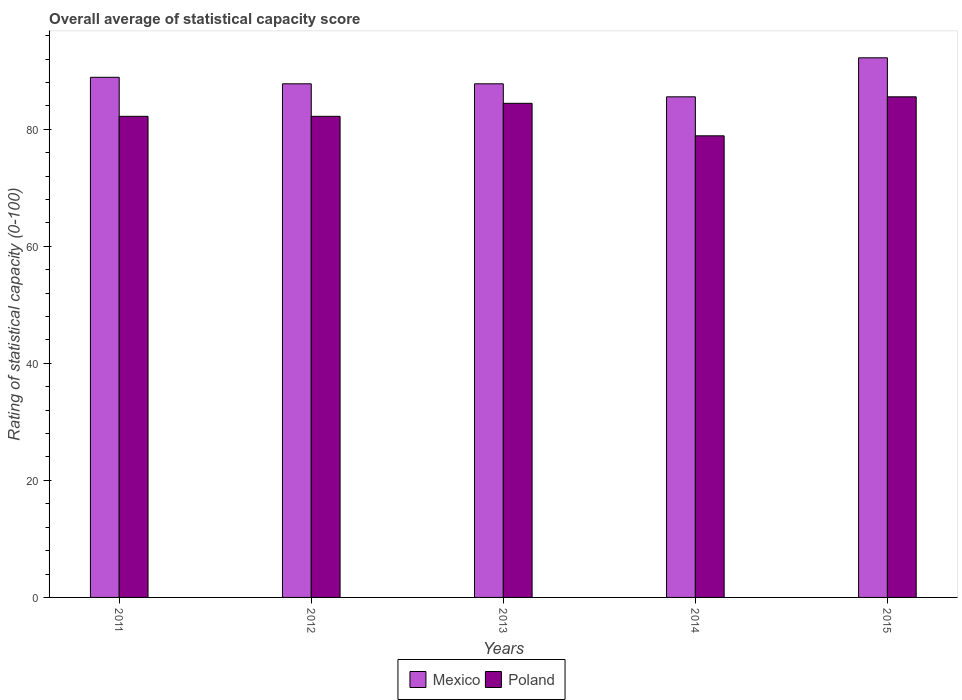Are the number of bars per tick equal to the number of legend labels?
Your answer should be compact. Yes. Are the number of bars on each tick of the X-axis equal?
Offer a terse response. Yes. How many bars are there on the 2nd tick from the right?
Keep it short and to the point. 2. What is the label of the 5th group of bars from the left?
Ensure brevity in your answer.  2015. In how many cases, is the number of bars for a given year not equal to the number of legend labels?
Your answer should be very brief. 0. What is the rating of statistical capacity in Poland in 2012?
Your answer should be very brief. 82.22. Across all years, what is the maximum rating of statistical capacity in Poland?
Make the answer very short. 85.56. Across all years, what is the minimum rating of statistical capacity in Mexico?
Your response must be concise. 85.56. In which year was the rating of statistical capacity in Mexico maximum?
Your answer should be compact. 2015. What is the total rating of statistical capacity in Poland in the graph?
Offer a very short reply. 413.33. What is the difference between the rating of statistical capacity in Mexico in 2014 and that in 2015?
Your answer should be very brief. -6.67. What is the difference between the rating of statistical capacity in Poland in 2015 and the rating of statistical capacity in Mexico in 2014?
Keep it short and to the point. 1.1111111192008138e-5. What is the average rating of statistical capacity in Mexico per year?
Provide a short and direct response. 88.44. In the year 2011, what is the difference between the rating of statistical capacity in Poland and rating of statistical capacity in Mexico?
Your answer should be compact. -6.67. In how many years, is the rating of statistical capacity in Mexico greater than 16?
Ensure brevity in your answer.  5. Is the difference between the rating of statistical capacity in Poland in 2011 and 2013 greater than the difference between the rating of statistical capacity in Mexico in 2011 and 2013?
Provide a succinct answer. No. What is the difference between the highest and the second highest rating of statistical capacity in Poland?
Your response must be concise. 1.11. What is the difference between the highest and the lowest rating of statistical capacity in Poland?
Provide a succinct answer. 6.67. In how many years, is the rating of statistical capacity in Poland greater than the average rating of statistical capacity in Poland taken over all years?
Ensure brevity in your answer.  2. Is the sum of the rating of statistical capacity in Mexico in 2011 and 2015 greater than the maximum rating of statistical capacity in Poland across all years?
Offer a terse response. Yes. What does the 2nd bar from the left in 2013 represents?
Provide a short and direct response. Poland. Are all the bars in the graph horizontal?
Ensure brevity in your answer.  No. Are the values on the major ticks of Y-axis written in scientific E-notation?
Give a very brief answer. No. Does the graph contain any zero values?
Keep it short and to the point. No. Where does the legend appear in the graph?
Your answer should be compact. Bottom center. How are the legend labels stacked?
Make the answer very short. Horizontal. What is the title of the graph?
Offer a terse response. Overall average of statistical capacity score. Does "Latin America(all income levels)" appear as one of the legend labels in the graph?
Make the answer very short. No. What is the label or title of the X-axis?
Provide a short and direct response. Years. What is the label or title of the Y-axis?
Make the answer very short. Rating of statistical capacity (0-100). What is the Rating of statistical capacity (0-100) in Mexico in 2011?
Make the answer very short. 88.89. What is the Rating of statistical capacity (0-100) in Poland in 2011?
Make the answer very short. 82.22. What is the Rating of statistical capacity (0-100) in Mexico in 2012?
Give a very brief answer. 87.78. What is the Rating of statistical capacity (0-100) of Poland in 2012?
Give a very brief answer. 82.22. What is the Rating of statistical capacity (0-100) of Mexico in 2013?
Provide a short and direct response. 87.78. What is the Rating of statistical capacity (0-100) in Poland in 2013?
Ensure brevity in your answer.  84.44. What is the Rating of statistical capacity (0-100) of Mexico in 2014?
Offer a terse response. 85.56. What is the Rating of statistical capacity (0-100) in Poland in 2014?
Offer a terse response. 78.89. What is the Rating of statistical capacity (0-100) of Mexico in 2015?
Your answer should be very brief. 92.22. What is the Rating of statistical capacity (0-100) of Poland in 2015?
Give a very brief answer. 85.56. Across all years, what is the maximum Rating of statistical capacity (0-100) of Mexico?
Offer a very short reply. 92.22. Across all years, what is the maximum Rating of statistical capacity (0-100) of Poland?
Ensure brevity in your answer.  85.56. Across all years, what is the minimum Rating of statistical capacity (0-100) of Mexico?
Offer a very short reply. 85.56. Across all years, what is the minimum Rating of statistical capacity (0-100) of Poland?
Your answer should be compact. 78.89. What is the total Rating of statistical capacity (0-100) in Mexico in the graph?
Make the answer very short. 442.22. What is the total Rating of statistical capacity (0-100) of Poland in the graph?
Give a very brief answer. 413.33. What is the difference between the Rating of statistical capacity (0-100) of Mexico in 2011 and that in 2012?
Make the answer very short. 1.11. What is the difference between the Rating of statistical capacity (0-100) of Mexico in 2011 and that in 2013?
Give a very brief answer. 1.11. What is the difference between the Rating of statistical capacity (0-100) of Poland in 2011 and that in 2013?
Keep it short and to the point. -2.22. What is the difference between the Rating of statistical capacity (0-100) of Mexico in 2011 and that in 2014?
Give a very brief answer. 3.33. What is the difference between the Rating of statistical capacity (0-100) in Poland in 2011 and that in 2014?
Your response must be concise. 3.33. What is the difference between the Rating of statistical capacity (0-100) in Poland in 2012 and that in 2013?
Provide a short and direct response. -2.22. What is the difference between the Rating of statistical capacity (0-100) of Mexico in 2012 and that in 2014?
Ensure brevity in your answer.  2.22. What is the difference between the Rating of statistical capacity (0-100) of Poland in 2012 and that in 2014?
Offer a terse response. 3.33. What is the difference between the Rating of statistical capacity (0-100) of Mexico in 2012 and that in 2015?
Offer a terse response. -4.44. What is the difference between the Rating of statistical capacity (0-100) of Mexico in 2013 and that in 2014?
Provide a succinct answer. 2.22. What is the difference between the Rating of statistical capacity (0-100) of Poland in 2013 and that in 2014?
Ensure brevity in your answer.  5.56. What is the difference between the Rating of statistical capacity (0-100) of Mexico in 2013 and that in 2015?
Make the answer very short. -4.44. What is the difference between the Rating of statistical capacity (0-100) in Poland in 2013 and that in 2015?
Give a very brief answer. -1.11. What is the difference between the Rating of statistical capacity (0-100) of Mexico in 2014 and that in 2015?
Your response must be concise. -6.67. What is the difference between the Rating of statistical capacity (0-100) of Poland in 2014 and that in 2015?
Your response must be concise. -6.67. What is the difference between the Rating of statistical capacity (0-100) in Mexico in 2011 and the Rating of statistical capacity (0-100) in Poland in 2012?
Provide a succinct answer. 6.67. What is the difference between the Rating of statistical capacity (0-100) of Mexico in 2011 and the Rating of statistical capacity (0-100) of Poland in 2013?
Your answer should be compact. 4.44. What is the difference between the Rating of statistical capacity (0-100) in Mexico in 2011 and the Rating of statistical capacity (0-100) in Poland in 2014?
Keep it short and to the point. 10. What is the difference between the Rating of statistical capacity (0-100) of Mexico in 2011 and the Rating of statistical capacity (0-100) of Poland in 2015?
Provide a short and direct response. 3.33. What is the difference between the Rating of statistical capacity (0-100) in Mexico in 2012 and the Rating of statistical capacity (0-100) in Poland in 2014?
Your answer should be compact. 8.89. What is the difference between the Rating of statistical capacity (0-100) of Mexico in 2012 and the Rating of statistical capacity (0-100) of Poland in 2015?
Give a very brief answer. 2.22. What is the difference between the Rating of statistical capacity (0-100) in Mexico in 2013 and the Rating of statistical capacity (0-100) in Poland in 2014?
Your answer should be very brief. 8.89. What is the difference between the Rating of statistical capacity (0-100) of Mexico in 2013 and the Rating of statistical capacity (0-100) of Poland in 2015?
Offer a terse response. 2.22. What is the difference between the Rating of statistical capacity (0-100) of Mexico in 2014 and the Rating of statistical capacity (0-100) of Poland in 2015?
Ensure brevity in your answer.  -0. What is the average Rating of statistical capacity (0-100) in Mexico per year?
Your answer should be very brief. 88.44. What is the average Rating of statistical capacity (0-100) in Poland per year?
Your response must be concise. 82.67. In the year 2012, what is the difference between the Rating of statistical capacity (0-100) in Mexico and Rating of statistical capacity (0-100) in Poland?
Your answer should be very brief. 5.56. In the year 2013, what is the difference between the Rating of statistical capacity (0-100) in Mexico and Rating of statistical capacity (0-100) in Poland?
Offer a very short reply. 3.33. In the year 2015, what is the difference between the Rating of statistical capacity (0-100) in Mexico and Rating of statistical capacity (0-100) in Poland?
Offer a terse response. 6.67. What is the ratio of the Rating of statistical capacity (0-100) in Mexico in 2011 to that in 2012?
Offer a terse response. 1.01. What is the ratio of the Rating of statistical capacity (0-100) of Poland in 2011 to that in 2012?
Your response must be concise. 1. What is the ratio of the Rating of statistical capacity (0-100) in Mexico in 2011 to that in 2013?
Ensure brevity in your answer.  1.01. What is the ratio of the Rating of statistical capacity (0-100) of Poland in 2011 to that in 2013?
Offer a very short reply. 0.97. What is the ratio of the Rating of statistical capacity (0-100) of Mexico in 2011 to that in 2014?
Your answer should be very brief. 1.04. What is the ratio of the Rating of statistical capacity (0-100) in Poland in 2011 to that in 2014?
Your response must be concise. 1.04. What is the ratio of the Rating of statistical capacity (0-100) in Mexico in 2011 to that in 2015?
Your response must be concise. 0.96. What is the ratio of the Rating of statistical capacity (0-100) in Mexico in 2012 to that in 2013?
Your response must be concise. 1. What is the ratio of the Rating of statistical capacity (0-100) of Poland in 2012 to that in 2013?
Your response must be concise. 0.97. What is the ratio of the Rating of statistical capacity (0-100) of Mexico in 2012 to that in 2014?
Offer a terse response. 1.03. What is the ratio of the Rating of statistical capacity (0-100) of Poland in 2012 to that in 2014?
Make the answer very short. 1.04. What is the ratio of the Rating of statistical capacity (0-100) in Mexico in 2012 to that in 2015?
Offer a terse response. 0.95. What is the ratio of the Rating of statistical capacity (0-100) in Poland in 2012 to that in 2015?
Your answer should be compact. 0.96. What is the ratio of the Rating of statistical capacity (0-100) of Poland in 2013 to that in 2014?
Ensure brevity in your answer.  1.07. What is the ratio of the Rating of statistical capacity (0-100) of Mexico in 2013 to that in 2015?
Give a very brief answer. 0.95. What is the ratio of the Rating of statistical capacity (0-100) of Mexico in 2014 to that in 2015?
Make the answer very short. 0.93. What is the ratio of the Rating of statistical capacity (0-100) in Poland in 2014 to that in 2015?
Your answer should be compact. 0.92. What is the difference between the highest and the second highest Rating of statistical capacity (0-100) of Mexico?
Your response must be concise. 3.33. What is the difference between the highest and the lowest Rating of statistical capacity (0-100) in Poland?
Give a very brief answer. 6.67. 